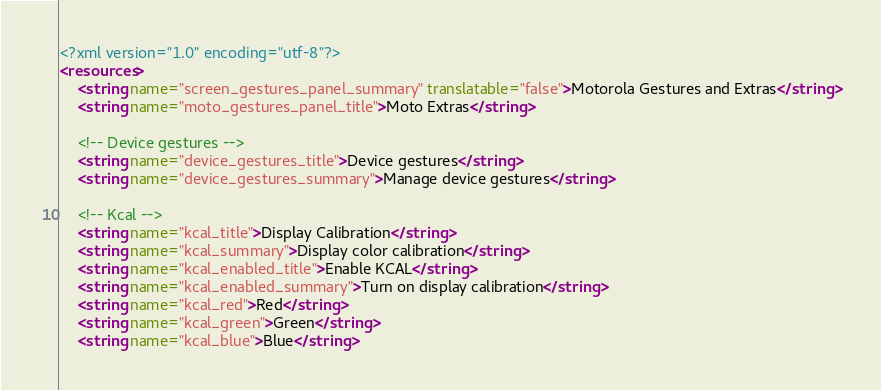Convert code to text. <code><loc_0><loc_0><loc_500><loc_500><_XML_><?xml version="1.0" encoding="utf-8"?>
<resources>
    <string name="screen_gestures_panel_summary" translatable="false">Motorola Gestures and Extras</string>
    <string name="moto_gestures_panel_title">Moto Extras</string>

    <!-- Device gestures -->
    <string name="device_gestures_title">Device gestures</string>
    <string name="device_gestures_summary">Manage device gestures</string>

    <!-- Kcal -->
    <string name="kcal_title">Display Calibration</string>
    <string name="kcal_summary">Display color calibration</string>
    <string name="kcal_enabled_title">Enable KCAL</string>
    <string name="kcal_enabled_summary">Turn on display calibration</string>
    <string name="kcal_red">Red</string>
    <string name="kcal_green">Green</string>
    <string name="kcal_blue">Blue</string></code> 